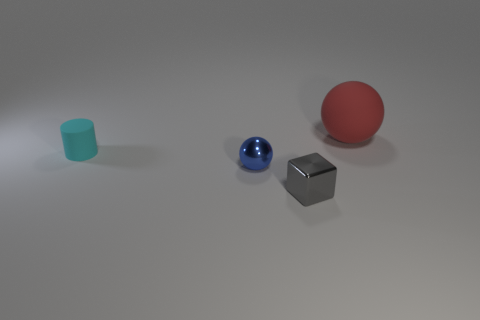There is another object that is the same shape as the large red object; what is its material?
Make the answer very short. Metal. The gray thing has what shape?
Make the answer very short. Cube. There is a small block that is to the right of the matte object that is in front of the rubber object right of the small cyan rubber thing; what is it made of?
Provide a short and direct response. Metal. What number of other objects are there of the same material as the tiny gray block?
Provide a short and direct response. 1. What number of cyan matte things are on the right side of the tiny metallic thing that is to the left of the gray shiny thing?
Provide a succinct answer. 0. What number of balls are either large yellow metal things or big objects?
Provide a succinct answer. 1. What is the color of the object that is both right of the small blue shiny object and in front of the tiny cylinder?
Provide a short and direct response. Gray. Is there any other thing that has the same color as the large sphere?
Keep it short and to the point. No. The object that is in front of the sphere on the left side of the red matte ball is what color?
Offer a terse response. Gray. Does the cube have the same size as the cyan object?
Provide a succinct answer. Yes. 